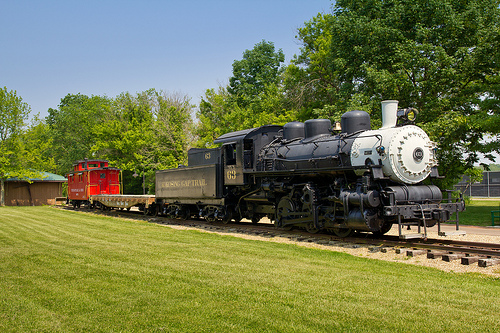<image>
Is there a train on the track? Yes. Looking at the image, I can see the train is positioned on top of the track, with the track providing support. 